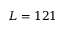<formula> <loc_0><loc_0><loc_500><loc_500>L = 1 2 1</formula> 